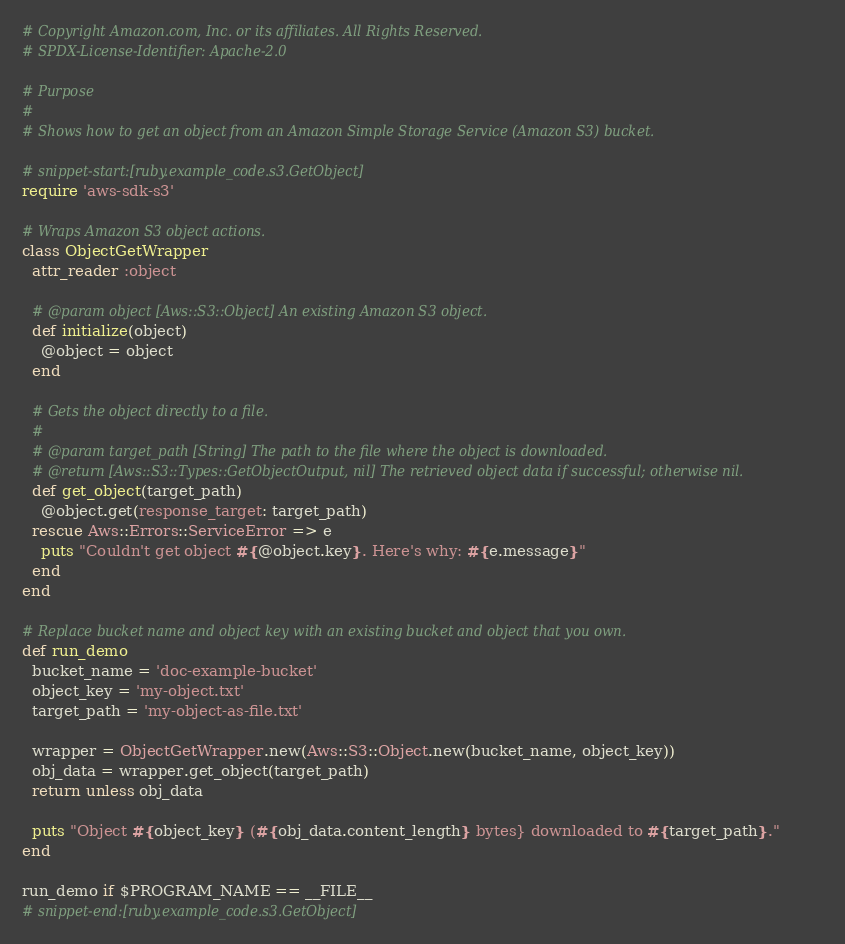<code> <loc_0><loc_0><loc_500><loc_500><_Ruby_># Copyright Amazon.com, Inc. or its affiliates. All Rights Reserved.
# SPDX-License-Identifier: Apache-2.0

# Purpose
#
# Shows how to get an object from an Amazon Simple Storage Service (Amazon S3) bucket.

# snippet-start:[ruby.example_code.s3.GetObject]
require 'aws-sdk-s3'

# Wraps Amazon S3 object actions.
class ObjectGetWrapper
  attr_reader :object

  # @param object [Aws::S3::Object] An existing Amazon S3 object.
  def initialize(object)
    @object = object
  end

  # Gets the object directly to a file.
  #
  # @param target_path [String] The path to the file where the object is downloaded.
  # @return [Aws::S3::Types::GetObjectOutput, nil] The retrieved object data if successful; otherwise nil.
  def get_object(target_path)
    @object.get(response_target: target_path)
  rescue Aws::Errors::ServiceError => e
    puts "Couldn't get object #{@object.key}. Here's why: #{e.message}"
  end
end

# Replace bucket name and object key with an existing bucket and object that you own.
def run_demo
  bucket_name = 'doc-example-bucket'
  object_key = 'my-object.txt'
  target_path = 'my-object-as-file.txt'

  wrapper = ObjectGetWrapper.new(Aws::S3::Object.new(bucket_name, object_key))
  obj_data = wrapper.get_object(target_path)
  return unless obj_data

  puts "Object #{object_key} (#{obj_data.content_length} bytes} downloaded to #{target_path}."
end

run_demo if $PROGRAM_NAME == __FILE__
# snippet-end:[ruby.example_code.s3.GetObject]
</code> 